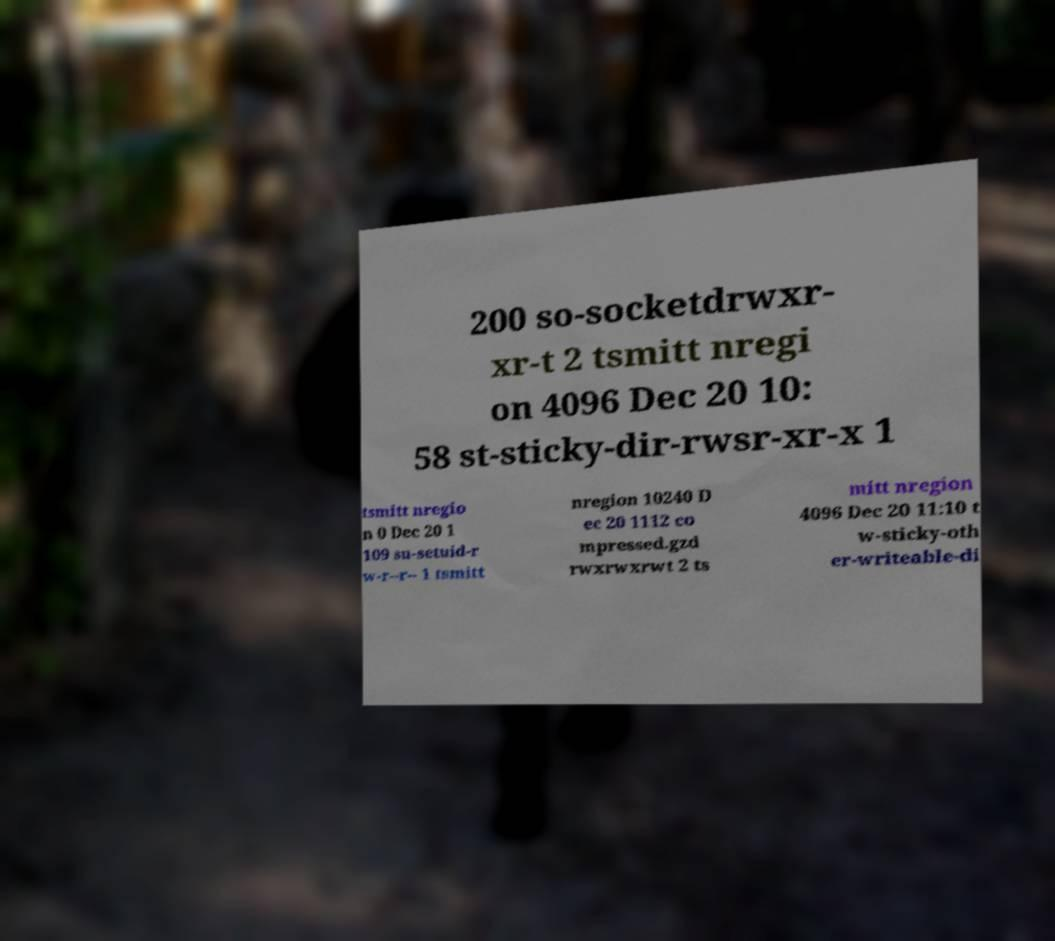For documentation purposes, I need the text within this image transcribed. Could you provide that? 200 so-socketdrwxr- xr-t 2 tsmitt nregi on 4096 Dec 20 10: 58 st-sticky-dir-rwsr-xr-x 1 tsmitt nregio n 0 Dec 20 1 109 su-setuid-r w-r--r-- 1 tsmitt nregion 10240 D ec 20 1112 co mpressed.gzd rwxrwxrwt 2 ts mitt nregion 4096 Dec 20 11:10 t w-sticky-oth er-writeable-di 